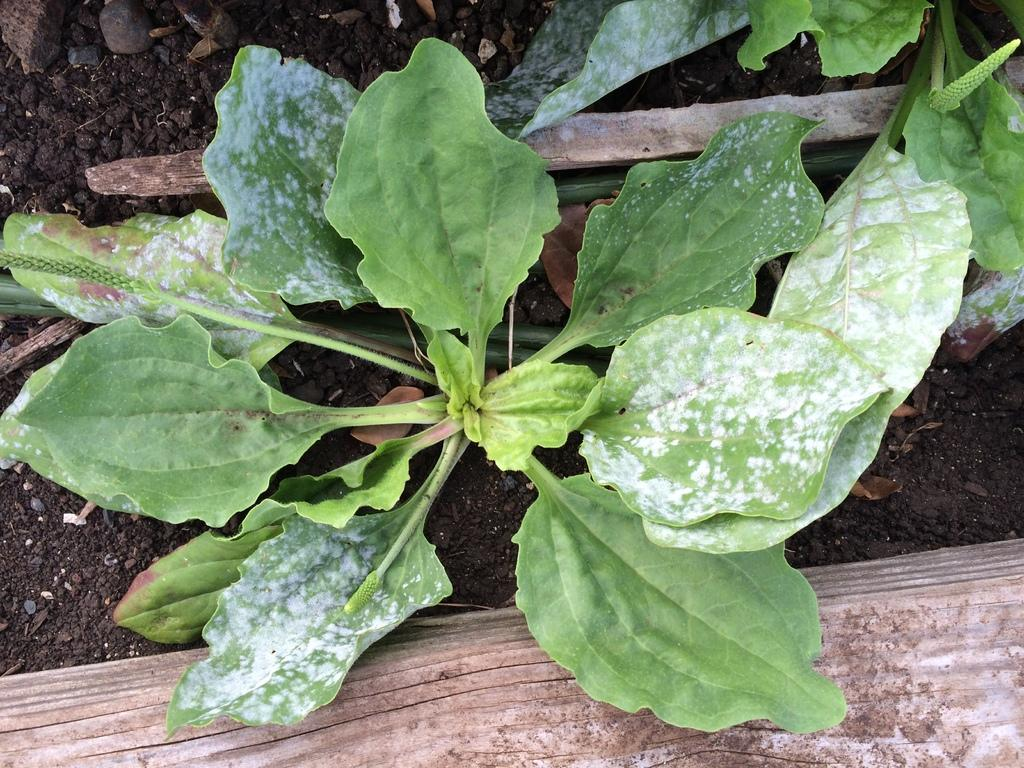What type of living organisms are in the image? There are plants in the image. What color are the plants in the image? The plants are in green color. Can you describe any other objects in the image? There is a stick at the top of the image. What type of game is being played in the image? There is no game present in the image; it features plants and a stick. Is there a prison visible in the image? There is no prison present in the image. 